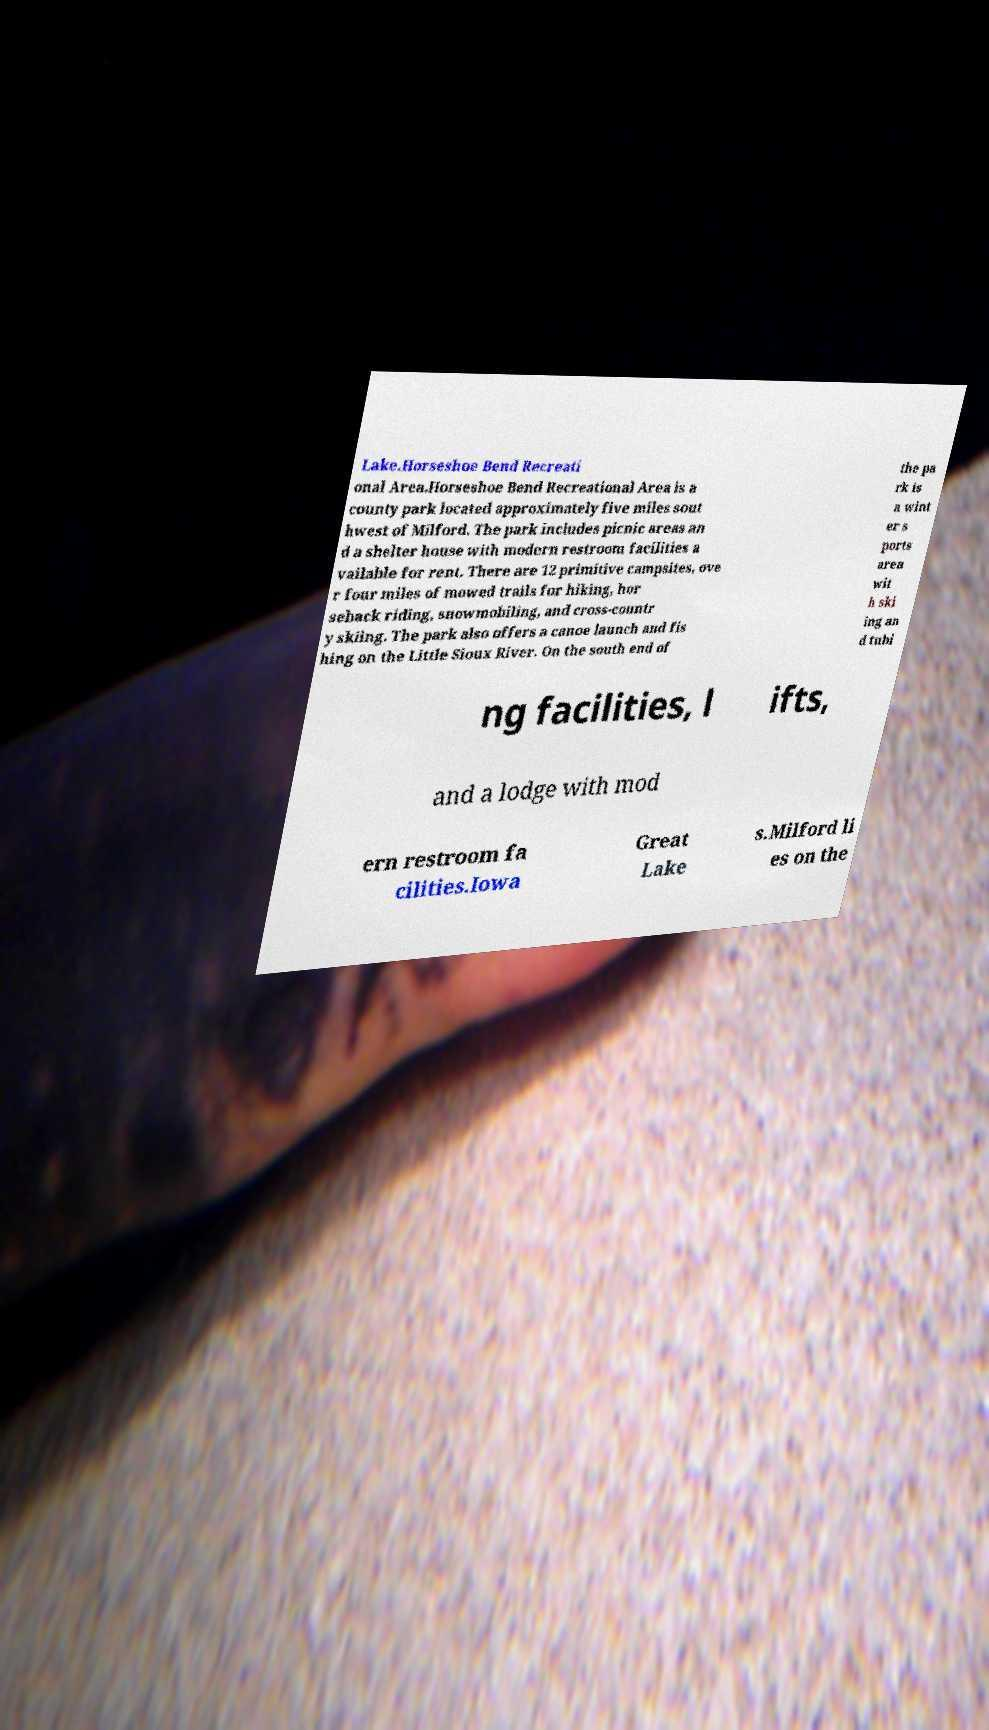Can you read and provide the text displayed in the image?This photo seems to have some interesting text. Can you extract and type it out for me? Lake.Horseshoe Bend Recreati onal Area.Horseshoe Bend Recreational Area is a county park located approximately five miles sout hwest of Milford. The park includes picnic areas an d a shelter house with modern restroom facilities a vailable for rent. There are 12 primitive campsites, ove r four miles of mowed trails for hiking, hor seback riding, snowmobiling, and cross-countr y skiing. The park also offers a canoe launch and fis hing on the Little Sioux River. On the south end of the pa rk is a wint er s ports area wit h ski ing an d tubi ng facilities, l ifts, and a lodge with mod ern restroom fa cilities.Iowa Great Lake s.Milford li es on the 